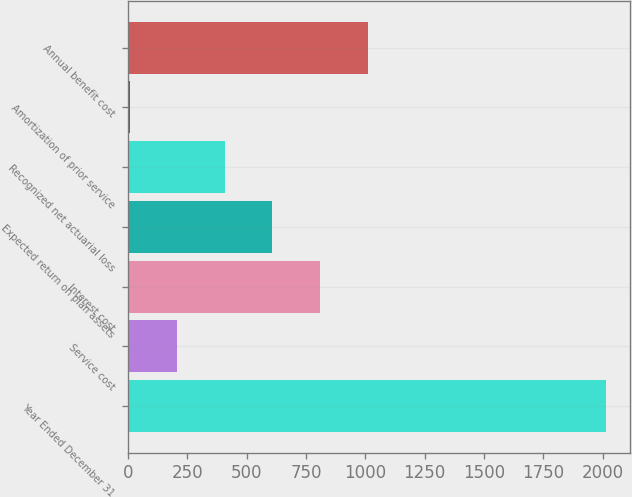<chart> <loc_0><loc_0><loc_500><loc_500><bar_chart><fcel>Year Ended December 31<fcel>Service cost<fcel>Interest cost<fcel>Expected return on plan assets<fcel>Recognized net actuarial loss<fcel>Amortization of prior service<fcel>Annual benefit cost<nl><fcel>2013<fcel>207.6<fcel>809.4<fcel>608.8<fcel>408.2<fcel>7<fcel>1010<nl></chart> 